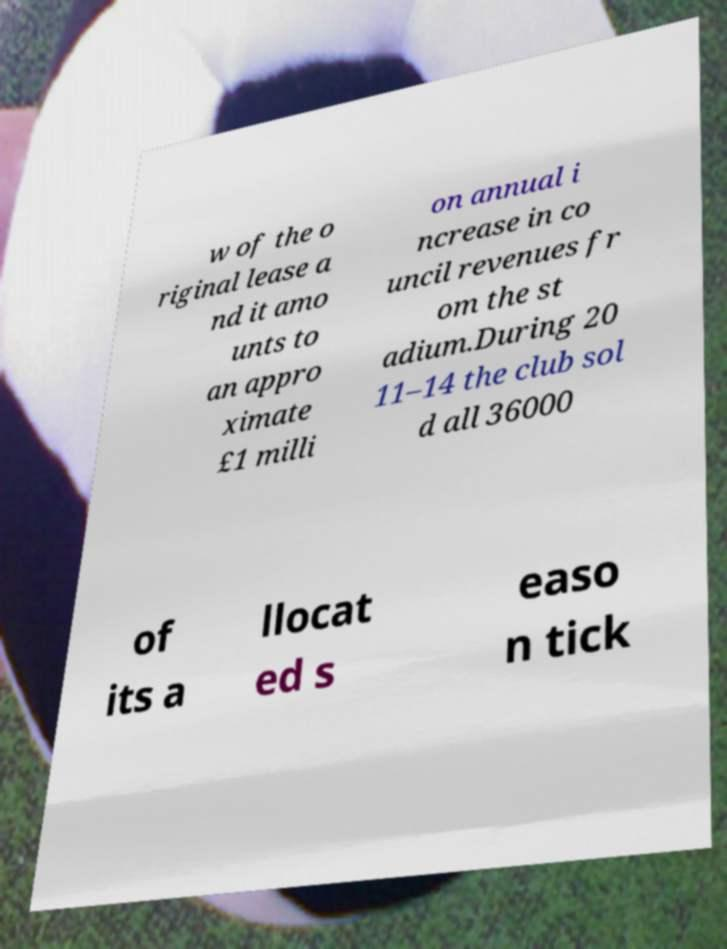Can you accurately transcribe the text from the provided image for me? w of the o riginal lease a nd it amo unts to an appro ximate £1 milli on annual i ncrease in co uncil revenues fr om the st adium.During 20 11–14 the club sol d all 36000 of its a llocat ed s easo n tick 